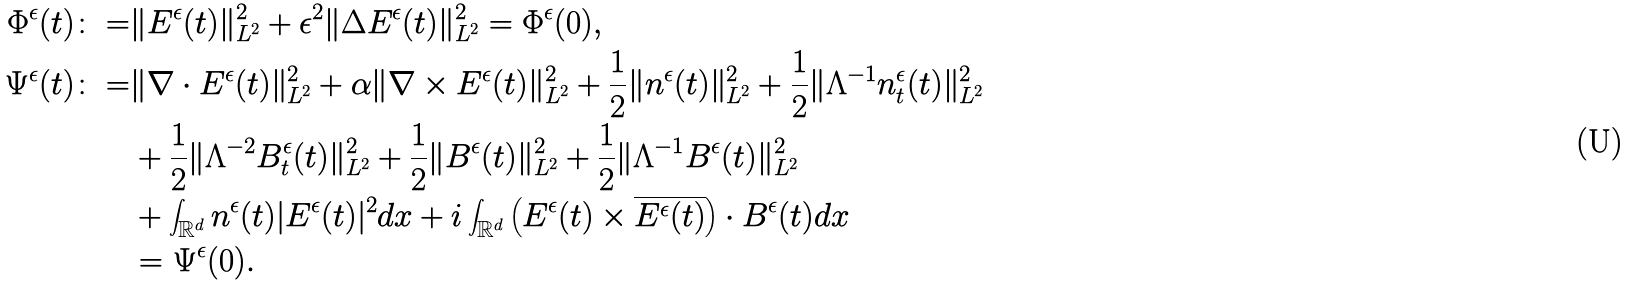Convert formula to latex. <formula><loc_0><loc_0><loc_500><loc_500>\Phi ^ { \epsilon } ( t ) \colon = & \| E ^ { \epsilon } ( t ) \| _ { L ^ { 2 } } ^ { 2 } + \epsilon ^ { 2 } \| \Delta E ^ { \epsilon } ( t ) \| _ { L ^ { 2 } } ^ { 2 } = \Phi ^ { \epsilon } ( 0 ) , \\ \Psi ^ { \epsilon } ( t ) \colon = & \| \nabla \cdot E ^ { \epsilon } ( t ) \| _ { L ^ { 2 } } ^ { 2 } + \alpha \| \nabla \times E ^ { \epsilon } ( t ) \| _ { L ^ { 2 } } ^ { 2 } + \frac { 1 } { 2 } \| n ^ { \epsilon } ( t ) \| _ { L ^ { 2 } } ^ { 2 } + \frac { 1 } { 2 } \| \Lambda ^ { - 1 } n ^ { \epsilon } _ { t } ( t ) \| _ { L ^ { 2 } } ^ { 2 } \\ & + \frac { 1 } { 2 } \| \Lambda ^ { - 2 } B ^ { \epsilon } _ { t } ( t ) \| _ { L ^ { 2 } } ^ { 2 } + \frac { 1 } { 2 } \| B ^ { \epsilon } ( t ) \| _ { L ^ { 2 } } ^ { 2 } + \frac { 1 } { 2 } \| \Lambda ^ { - 1 } B ^ { \epsilon } ( t ) \| _ { L ^ { 2 } } ^ { 2 } \\ & + \int _ { \mathbb { R } ^ { d } } n ^ { \epsilon } ( t ) | E ^ { \epsilon } ( t ) | ^ { 2 } d x + i \int _ { \mathbb { R } ^ { d } } \left ( E ^ { \epsilon } ( t ) \times \overline { E ^ { \epsilon } ( t ) } \right ) \cdot B ^ { \epsilon } ( t ) d x \\ & = \Psi ^ { \epsilon } ( 0 ) .</formula> 